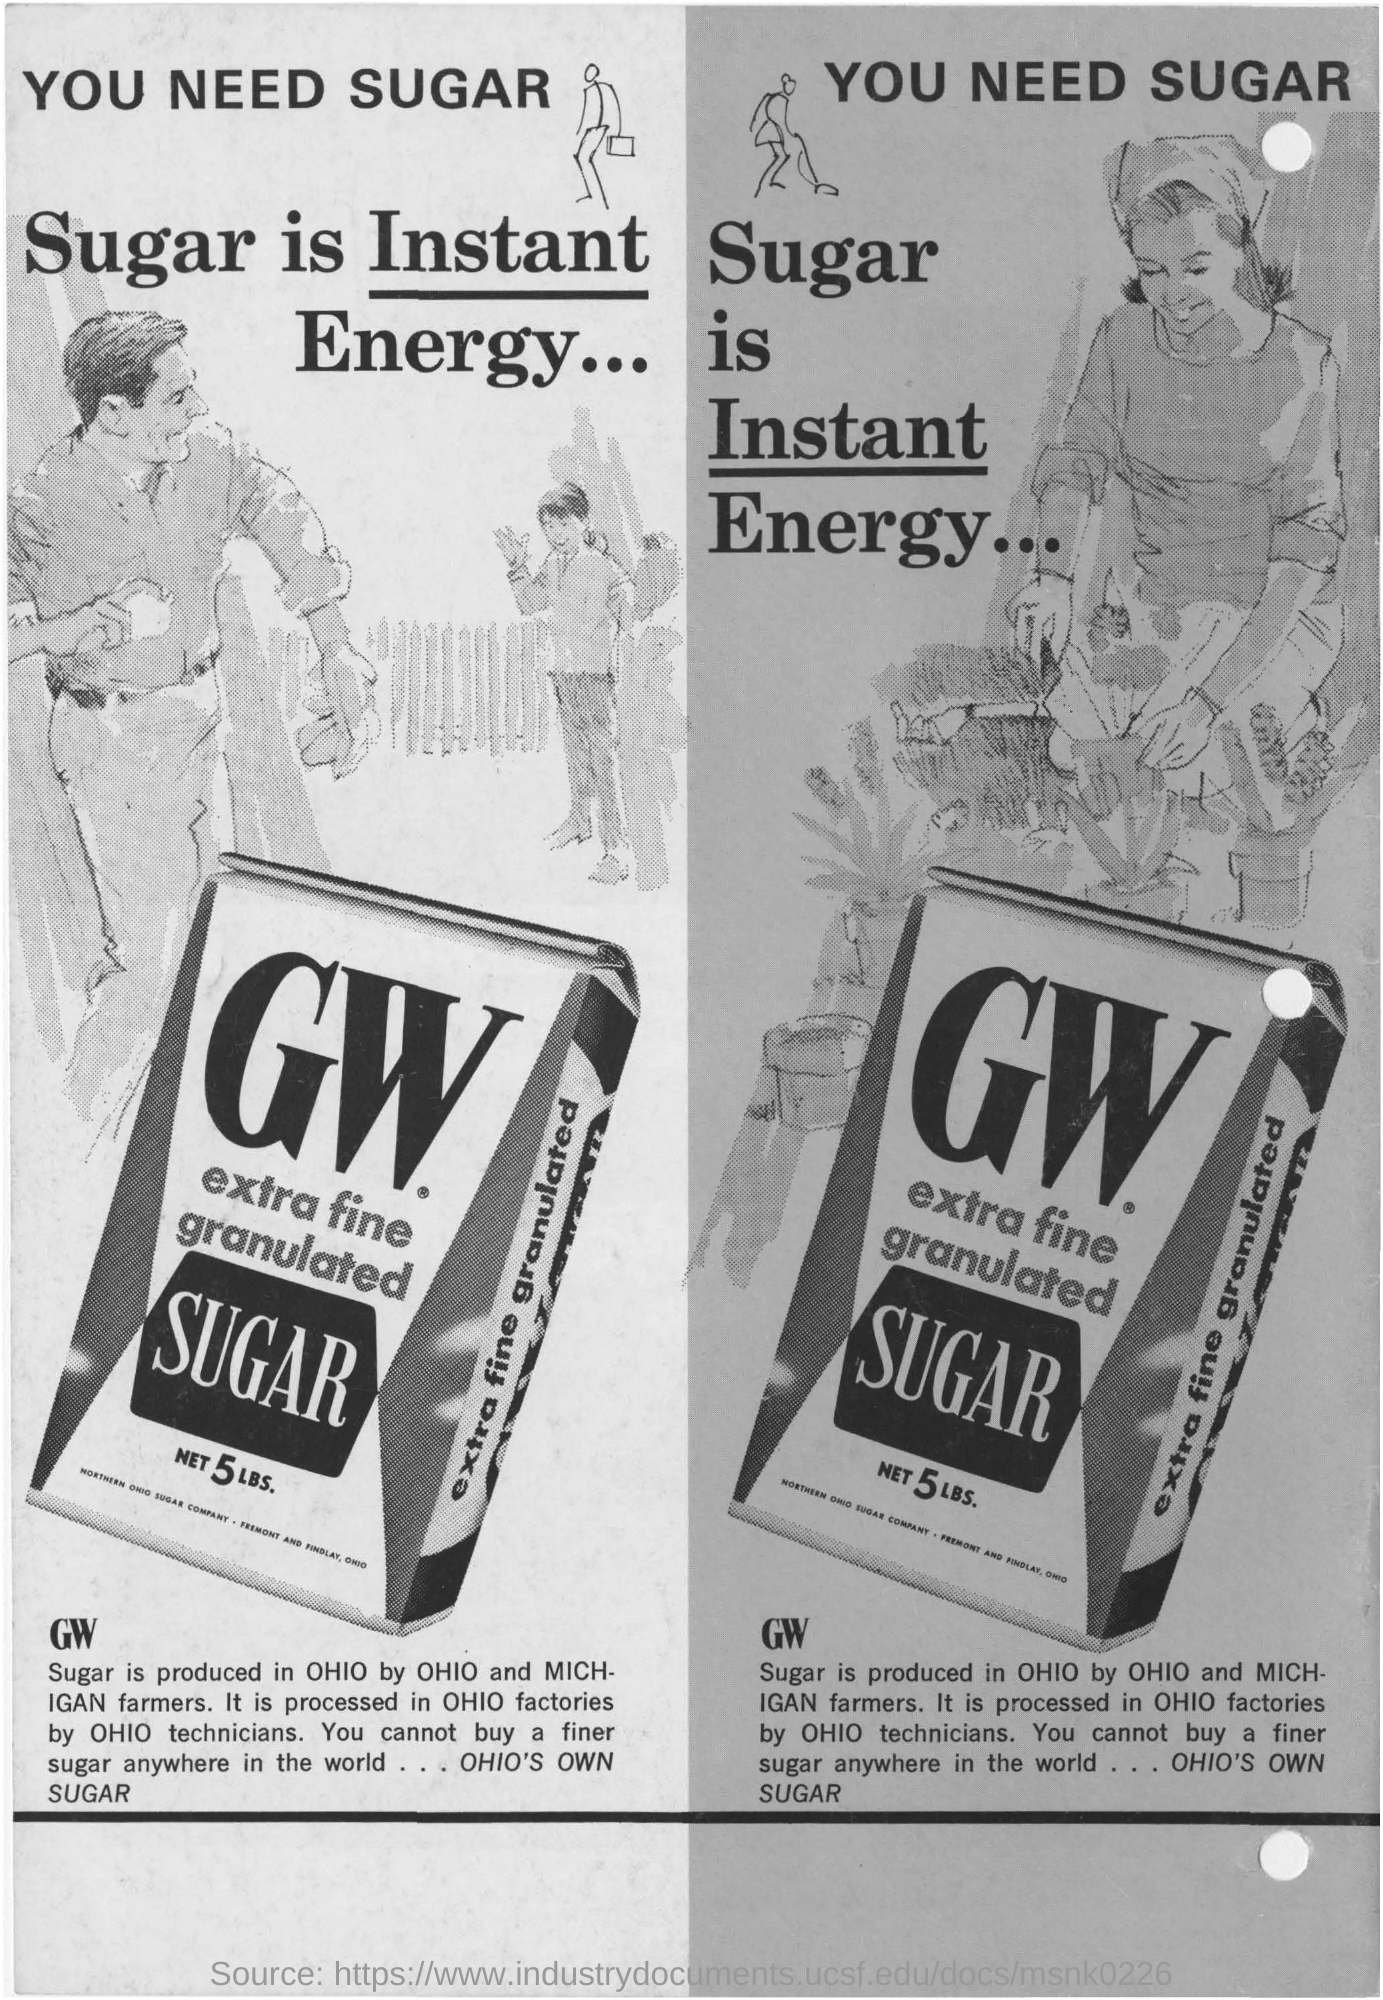In which state , GW Sugar is produced?
Your answer should be compact. OHIO. Who produces GW Sugar?
Keep it short and to the point. By ohio and michigan farmers. Where is the GW Sugar being processed?
Provide a short and direct response. In ohio factories. 